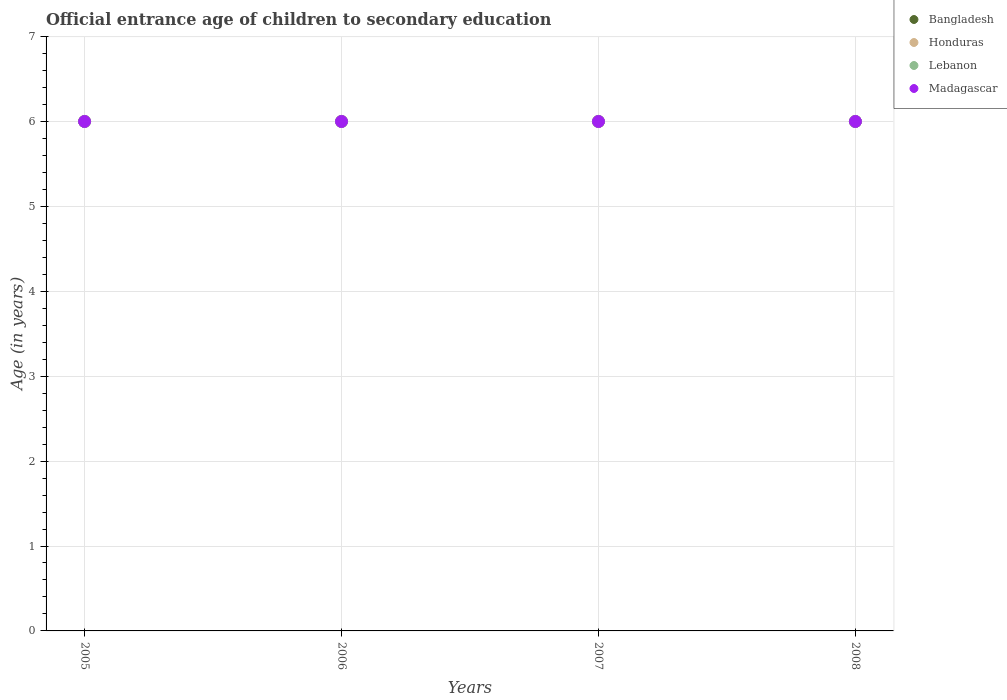Is the number of dotlines equal to the number of legend labels?
Provide a short and direct response. Yes. Across all years, what is the maximum secondary school starting age of children in Madagascar?
Keep it short and to the point. 6. Across all years, what is the minimum secondary school starting age of children in Honduras?
Offer a very short reply. 6. What is the total secondary school starting age of children in Bangladesh in the graph?
Keep it short and to the point. 24. In the year 2005, what is the difference between the secondary school starting age of children in Honduras and secondary school starting age of children in Madagascar?
Offer a terse response. 0. Is the secondary school starting age of children in Madagascar in 2005 less than that in 2007?
Provide a short and direct response. No. Is the difference between the secondary school starting age of children in Honduras in 2007 and 2008 greater than the difference between the secondary school starting age of children in Madagascar in 2007 and 2008?
Offer a very short reply. No. What is the difference between the highest and the second highest secondary school starting age of children in Madagascar?
Ensure brevity in your answer.  0. Is it the case that in every year, the sum of the secondary school starting age of children in Lebanon and secondary school starting age of children in Madagascar  is greater than the sum of secondary school starting age of children in Honduras and secondary school starting age of children in Bangladesh?
Make the answer very short. No. Does the secondary school starting age of children in Bangladesh monotonically increase over the years?
Offer a very short reply. No. Does the graph contain any zero values?
Keep it short and to the point. No. Does the graph contain grids?
Provide a succinct answer. Yes. Where does the legend appear in the graph?
Keep it short and to the point. Top right. How are the legend labels stacked?
Offer a terse response. Vertical. What is the title of the graph?
Your answer should be very brief. Official entrance age of children to secondary education. What is the label or title of the Y-axis?
Give a very brief answer. Age (in years). What is the Age (in years) in Lebanon in 2005?
Your response must be concise. 6. What is the Age (in years) of Honduras in 2006?
Give a very brief answer. 6. What is the Age (in years) in Bangladesh in 2007?
Provide a succinct answer. 6. What is the Age (in years) in Bangladesh in 2008?
Your answer should be compact. 6. What is the Age (in years) in Honduras in 2008?
Provide a short and direct response. 6. What is the Age (in years) of Lebanon in 2008?
Provide a succinct answer. 6. Across all years, what is the maximum Age (in years) of Honduras?
Your answer should be compact. 6. Across all years, what is the maximum Age (in years) of Lebanon?
Your answer should be very brief. 6. Across all years, what is the minimum Age (in years) of Bangladesh?
Ensure brevity in your answer.  6. Across all years, what is the minimum Age (in years) of Honduras?
Offer a terse response. 6. Across all years, what is the minimum Age (in years) of Lebanon?
Provide a succinct answer. 6. What is the total Age (in years) of Lebanon in the graph?
Your response must be concise. 24. What is the difference between the Age (in years) in Bangladesh in 2005 and that in 2007?
Offer a terse response. 0. What is the difference between the Age (in years) of Honduras in 2005 and that in 2007?
Give a very brief answer. 0. What is the difference between the Age (in years) in Lebanon in 2005 and that in 2007?
Offer a terse response. 0. What is the difference between the Age (in years) of Bangladesh in 2005 and that in 2008?
Keep it short and to the point. 0. What is the difference between the Age (in years) in Lebanon in 2005 and that in 2008?
Your answer should be very brief. 0. What is the difference between the Age (in years) in Honduras in 2006 and that in 2007?
Offer a terse response. 0. What is the difference between the Age (in years) of Bangladesh in 2006 and that in 2008?
Offer a very short reply. 0. What is the difference between the Age (in years) of Honduras in 2006 and that in 2008?
Your response must be concise. 0. What is the difference between the Age (in years) of Madagascar in 2006 and that in 2008?
Give a very brief answer. 0. What is the difference between the Age (in years) of Honduras in 2007 and that in 2008?
Your answer should be very brief. 0. What is the difference between the Age (in years) in Lebanon in 2007 and that in 2008?
Provide a short and direct response. 0. What is the difference between the Age (in years) of Madagascar in 2007 and that in 2008?
Provide a succinct answer. 0. What is the difference between the Age (in years) of Bangladesh in 2005 and the Age (in years) of Honduras in 2006?
Keep it short and to the point. 0. What is the difference between the Age (in years) in Bangladesh in 2005 and the Age (in years) in Lebanon in 2006?
Your answer should be very brief. 0. What is the difference between the Age (in years) of Honduras in 2005 and the Age (in years) of Lebanon in 2006?
Keep it short and to the point. 0. What is the difference between the Age (in years) of Honduras in 2005 and the Age (in years) of Madagascar in 2006?
Offer a very short reply. 0. What is the difference between the Age (in years) in Lebanon in 2005 and the Age (in years) in Madagascar in 2006?
Ensure brevity in your answer.  0. What is the difference between the Age (in years) of Bangladesh in 2005 and the Age (in years) of Honduras in 2007?
Provide a short and direct response. 0. What is the difference between the Age (in years) of Bangladesh in 2005 and the Age (in years) of Lebanon in 2007?
Give a very brief answer. 0. What is the difference between the Age (in years) of Bangladesh in 2005 and the Age (in years) of Madagascar in 2007?
Offer a very short reply. 0. What is the difference between the Age (in years) of Honduras in 2005 and the Age (in years) of Lebanon in 2007?
Your answer should be compact. 0. What is the difference between the Age (in years) in Honduras in 2005 and the Age (in years) in Madagascar in 2007?
Your response must be concise. 0. What is the difference between the Age (in years) in Bangladesh in 2005 and the Age (in years) in Honduras in 2008?
Offer a very short reply. 0. What is the difference between the Age (in years) in Bangladesh in 2005 and the Age (in years) in Lebanon in 2008?
Your response must be concise. 0. What is the difference between the Age (in years) of Bangladesh in 2005 and the Age (in years) of Madagascar in 2008?
Offer a terse response. 0. What is the difference between the Age (in years) in Honduras in 2005 and the Age (in years) in Lebanon in 2008?
Offer a terse response. 0. What is the difference between the Age (in years) in Lebanon in 2005 and the Age (in years) in Madagascar in 2008?
Ensure brevity in your answer.  0. What is the difference between the Age (in years) of Bangladesh in 2006 and the Age (in years) of Honduras in 2007?
Give a very brief answer. 0. What is the difference between the Age (in years) of Bangladesh in 2006 and the Age (in years) of Lebanon in 2007?
Your answer should be very brief. 0. What is the difference between the Age (in years) in Bangladesh in 2006 and the Age (in years) in Madagascar in 2007?
Keep it short and to the point. 0. What is the difference between the Age (in years) in Lebanon in 2006 and the Age (in years) in Madagascar in 2007?
Make the answer very short. 0. What is the difference between the Age (in years) in Bangladesh in 2006 and the Age (in years) in Lebanon in 2008?
Make the answer very short. 0. What is the difference between the Age (in years) in Bangladesh in 2006 and the Age (in years) in Madagascar in 2008?
Your answer should be very brief. 0. What is the difference between the Age (in years) of Honduras in 2006 and the Age (in years) of Lebanon in 2008?
Make the answer very short. 0. What is the difference between the Age (in years) in Bangladesh in 2007 and the Age (in years) in Honduras in 2008?
Provide a succinct answer. 0. What is the difference between the Age (in years) of Bangladesh in 2007 and the Age (in years) of Madagascar in 2008?
Your answer should be compact. 0. What is the average Age (in years) of Bangladesh per year?
Provide a succinct answer. 6. What is the average Age (in years) of Honduras per year?
Make the answer very short. 6. What is the average Age (in years) of Lebanon per year?
Your response must be concise. 6. In the year 2005, what is the difference between the Age (in years) in Bangladesh and Age (in years) in Honduras?
Provide a short and direct response. 0. In the year 2005, what is the difference between the Age (in years) of Bangladesh and Age (in years) of Madagascar?
Keep it short and to the point. 0. In the year 2005, what is the difference between the Age (in years) in Honduras and Age (in years) in Lebanon?
Your response must be concise. 0. In the year 2005, what is the difference between the Age (in years) of Lebanon and Age (in years) of Madagascar?
Your answer should be compact. 0. In the year 2006, what is the difference between the Age (in years) of Bangladesh and Age (in years) of Honduras?
Offer a very short reply. 0. In the year 2006, what is the difference between the Age (in years) in Bangladesh and Age (in years) in Madagascar?
Give a very brief answer. 0. In the year 2006, what is the difference between the Age (in years) of Honduras and Age (in years) of Lebanon?
Provide a short and direct response. 0. In the year 2006, what is the difference between the Age (in years) of Lebanon and Age (in years) of Madagascar?
Ensure brevity in your answer.  0. In the year 2007, what is the difference between the Age (in years) in Bangladesh and Age (in years) in Honduras?
Provide a short and direct response. 0. In the year 2007, what is the difference between the Age (in years) in Bangladesh and Age (in years) in Lebanon?
Your answer should be very brief. 0. In the year 2007, what is the difference between the Age (in years) of Honduras and Age (in years) of Madagascar?
Your response must be concise. 0. In the year 2007, what is the difference between the Age (in years) of Lebanon and Age (in years) of Madagascar?
Ensure brevity in your answer.  0. In the year 2008, what is the difference between the Age (in years) of Honduras and Age (in years) of Lebanon?
Keep it short and to the point. 0. In the year 2008, what is the difference between the Age (in years) of Honduras and Age (in years) of Madagascar?
Provide a succinct answer. 0. In the year 2008, what is the difference between the Age (in years) of Lebanon and Age (in years) of Madagascar?
Keep it short and to the point. 0. What is the ratio of the Age (in years) of Honduras in 2005 to that in 2006?
Provide a short and direct response. 1. What is the ratio of the Age (in years) of Lebanon in 2005 to that in 2006?
Keep it short and to the point. 1. What is the ratio of the Age (in years) in Bangladesh in 2005 to that in 2007?
Offer a terse response. 1. What is the ratio of the Age (in years) of Lebanon in 2005 to that in 2007?
Make the answer very short. 1. What is the ratio of the Age (in years) of Madagascar in 2005 to that in 2007?
Your response must be concise. 1. What is the ratio of the Age (in years) of Honduras in 2005 to that in 2008?
Make the answer very short. 1. What is the ratio of the Age (in years) in Madagascar in 2005 to that in 2008?
Make the answer very short. 1. What is the ratio of the Age (in years) in Bangladesh in 2006 to that in 2007?
Provide a short and direct response. 1. What is the ratio of the Age (in years) in Lebanon in 2006 to that in 2007?
Give a very brief answer. 1. What is the ratio of the Age (in years) in Bangladesh in 2006 to that in 2008?
Make the answer very short. 1. What is the ratio of the Age (in years) in Honduras in 2006 to that in 2008?
Offer a terse response. 1. What is the ratio of the Age (in years) in Madagascar in 2006 to that in 2008?
Ensure brevity in your answer.  1. What is the ratio of the Age (in years) of Bangladesh in 2007 to that in 2008?
Your answer should be very brief. 1. What is the difference between the highest and the second highest Age (in years) in Honduras?
Make the answer very short. 0. What is the difference between the highest and the lowest Age (in years) in Honduras?
Provide a succinct answer. 0. What is the difference between the highest and the lowest Age (in years) in Madagascar?
Your answer should be very brief. 0. 